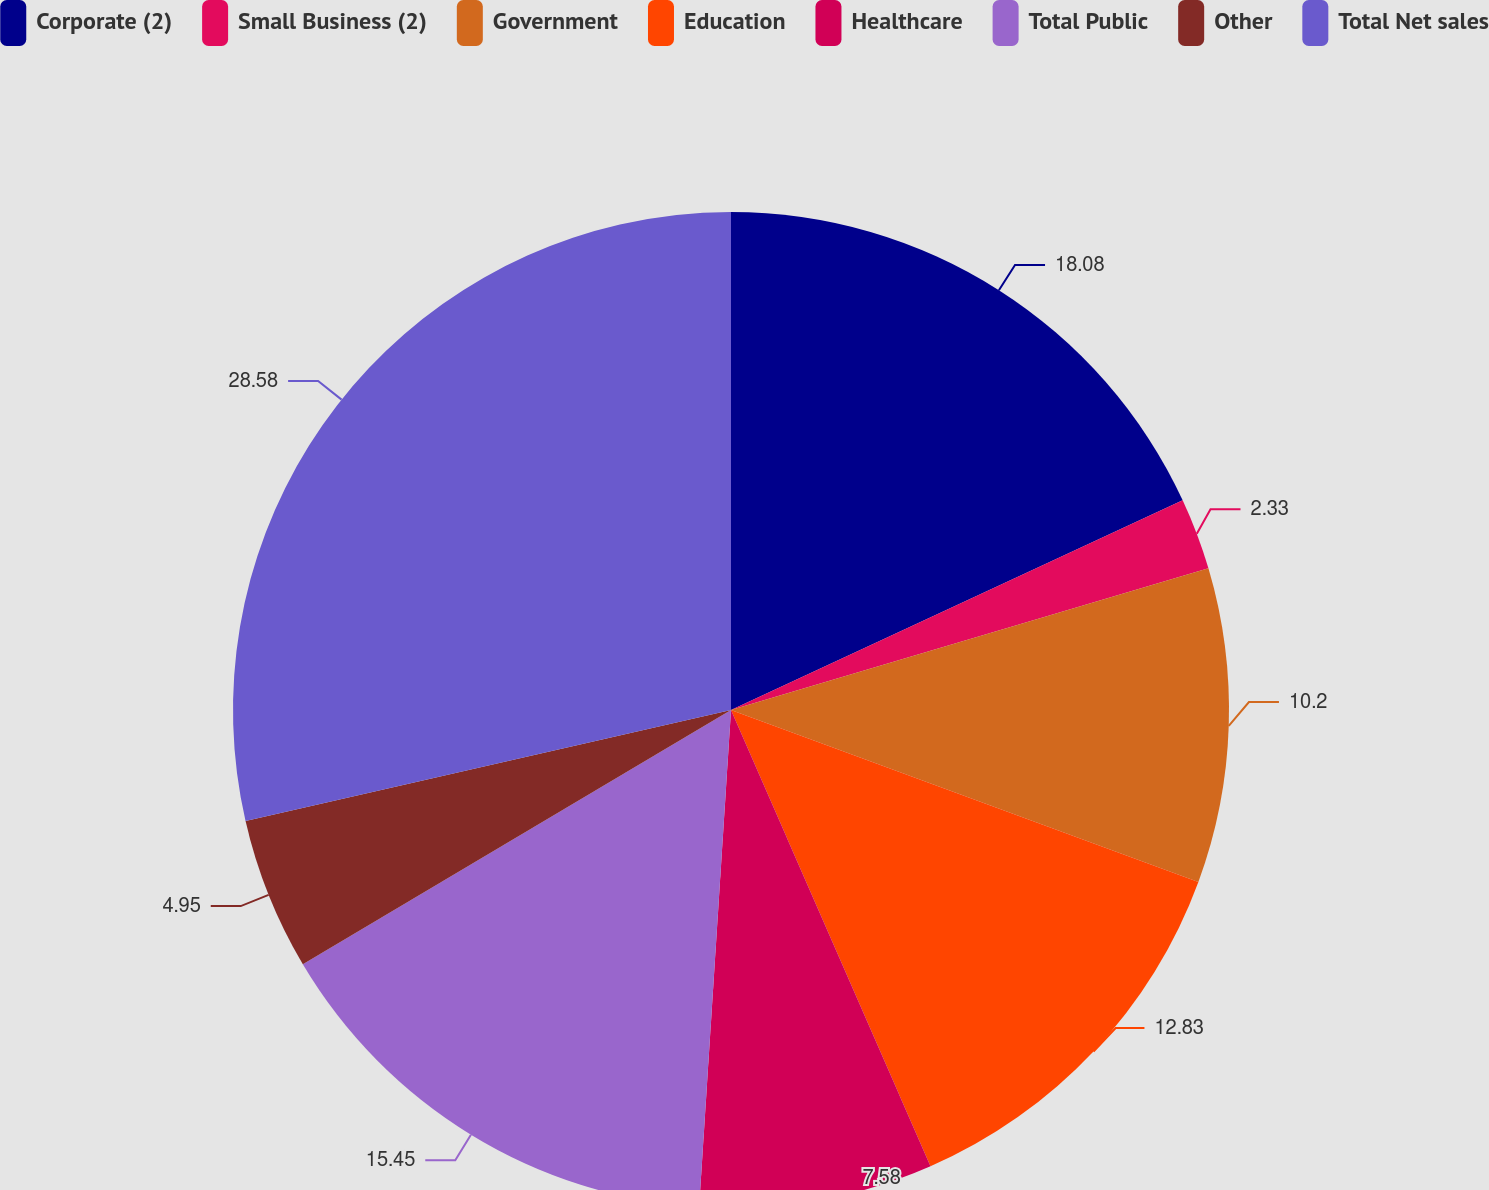Convert chart. <chart><loc_0><loc_0><loc_500><loc_500><pie_chart><fcel>Corporate (2)<fcel>Small Business (2)<fcel>Government<fcel>Education<fcel>Healthcare<fcel>Total Public<fcel>Other<fcel>Total Net sales<nl><fcel>18.08%<fcel>2.33%<fcel>10.2%<fcel>12.83%<fcel>7.58%<fcel>15.45%<fcel>4.95%<fcel>28.58%<nl></chart> 